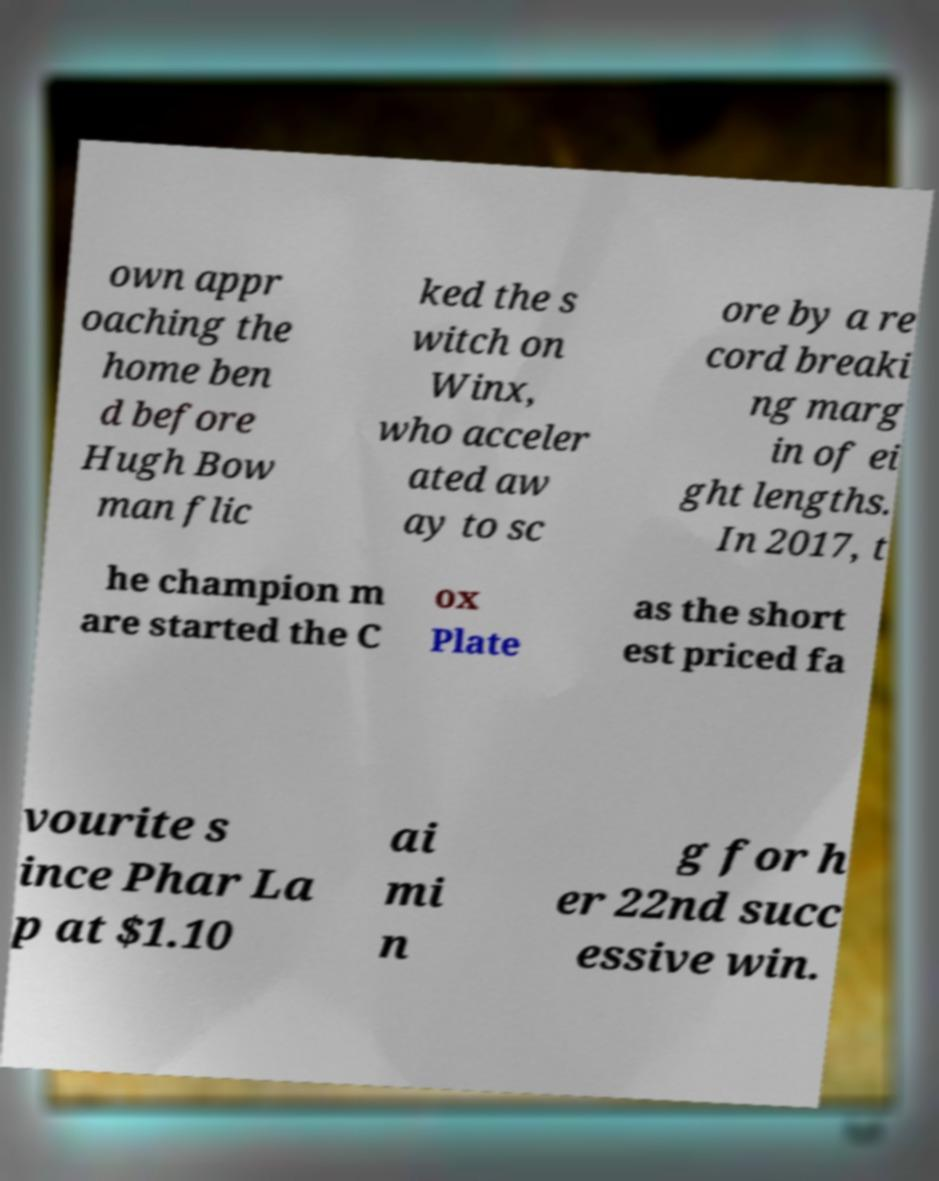There's text embedded in this image that I need extracted. Can you transcribe it verbatim? own appr oaching the home ben d before Hugh Bow man flic ked the s witch on Winx, who acceler ated aw ay to sc ore by a re cord breaki ng marg in of ei ght lengths. In 2017, t he champion m are started the C ox Plate as the short est priced fa vourite s ince Phar La p at $1.10 ai mi n g for h er 22nd succ essive win. 